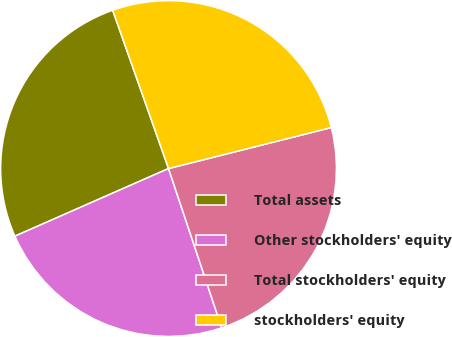<chart> <loc_0><loc_0><loc_500><loc_500><pie_chart><fcel>Total assets<fcel>Other stockholders' equity<fcel>Total stockholders' equity<fcel>stockholders' equity<nl><fcel>26.2%<fcel>23.53%<fcel>23.8%<fcel>26.47%<nl></chart> 